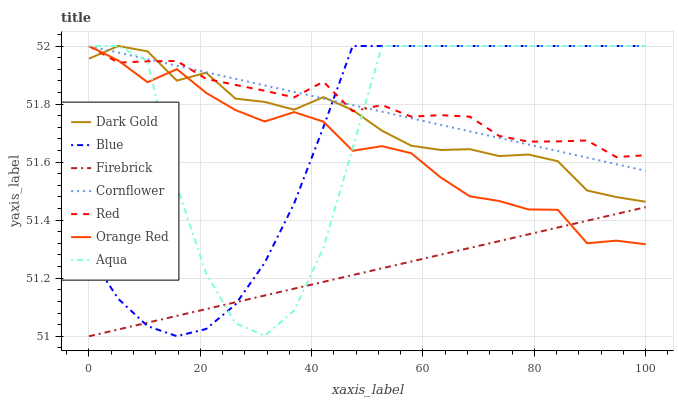Does Firebrick have the minimum area under the curve?
Answer yes or no. Yes. Does Red have the maximum area under the curve?
Answer yes or no. Yes. Does Cornflower have the minimum area under the curve?
Answer yes or no. No. Does Cornflower have the maximum area under the curve?
Answer yes or no. No. Is Cornflower the smoothest?
Answer yes or no. Yes. Is Aqua the roughest?
Answer yes or no. Yes. Is Dark Gold the smoothest?
Answer yes or no. No. Is Dark Gold the roughest?
Answer yes or no. No. Does Firebrick have the lowest value?
Answer yes or no. Yes. Does Cornflower have the lowest value?
Answer yes or no. No. Does Red have the highest value?
Answer yes or no. Yes. Does Firebrick have the highest value?
Answer yes or no. No. Is Firebrick less than Dark Gold?
Answer yes or no. Yes. Is Dark Gold greater than Firebrick?
Answer yes or no. Yes. Does Cornflower intersect Orange Red?
Answer yes or no. Yes. Is Cornflower less than Orange Red?
Answer yes or no. No. Is Cornflower greater than Orange Red?
Answer yes or no. No. Does Firebrick intersect Dark Gold?
Answer yes or no. No. 